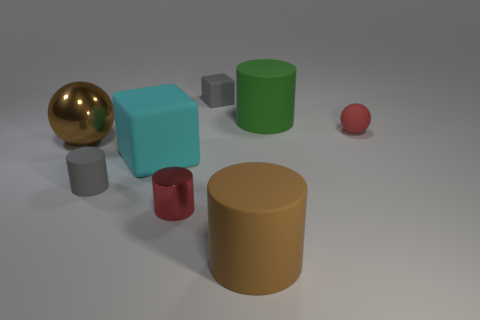How many big brown objects are there?
Your response must be concise. 2. How many objects are small red objects left of the brown cylinder or metallic objects to the right of the gray rubber cylinder?
Keep it short and to the point. 1. Does the cylinder that is in front of the metallic cylinder have the same size as the small red metal cylinder?
Offer a terse response. No. The brown matte thing that is the same shape as the small red shiny thing is what size?
Your answer should be compact. Large. What is the material of the green object that is the same size as the brown rubber object?
Ensure brevity in your answer.  Rubber. What material is the other large object that is the same shape as the large green matte object?
Keep it short and to the point. Rubber. What number of other things are the same size as the gray rubber cube?
Your response must be concise. 3. What size is the object that is the same color as the matte sphere?
Make the answer very short. Small. What number of large metal things have the same color as the metal cylinder?
Provide a short and direct response. 0. What is the shape of the large metal object?
Offer a very short reply. Sphere. 